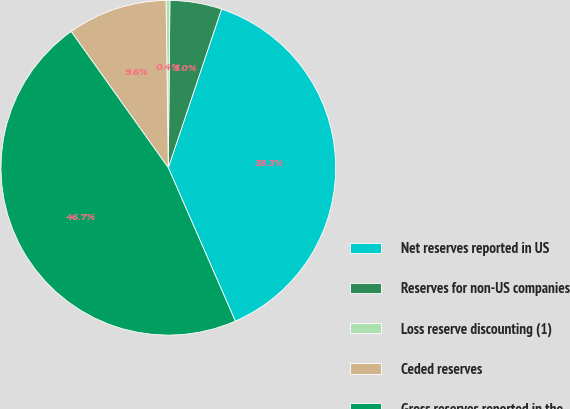Convert chart. <chart><loc_0><loc_0><loc_500><loc_500><pie_chart><fcel>Net reserves reported in US<fcel>Reserves for non-US companies<fcel>Loss reserve discounting (1)<fcel>Ceded reserves<fcel>Gross reserves reported in the<nl><fcel>38.29%<fcel>5.0%<fcel>0.37%<fcel>9.64%<fcel>46.7%<nl></chart> 